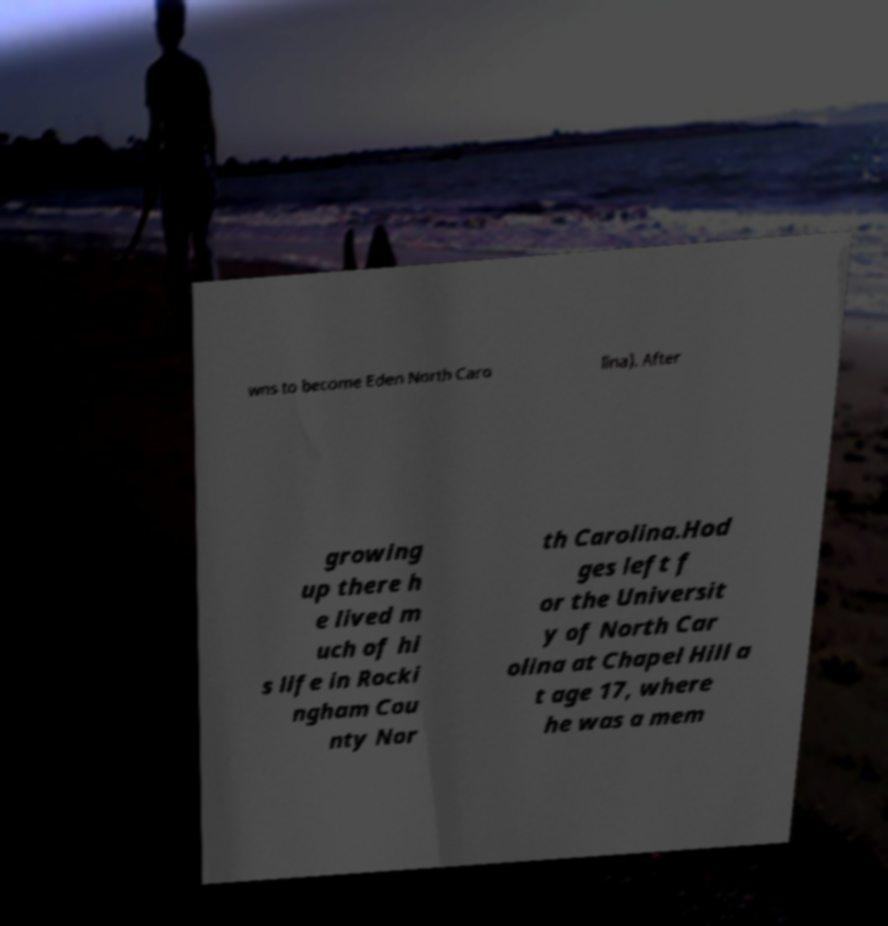Can you accurately transcribe the text from the provided image for me? wns to become Eden North Caro lina). After growing up there h e lived m uch of hi s life in Rocki ngham Cou nty Nor th Carolina.Hod ges left f or the Universit y of North Car olina at Chapel Hill a t age 17, where he was a mem 